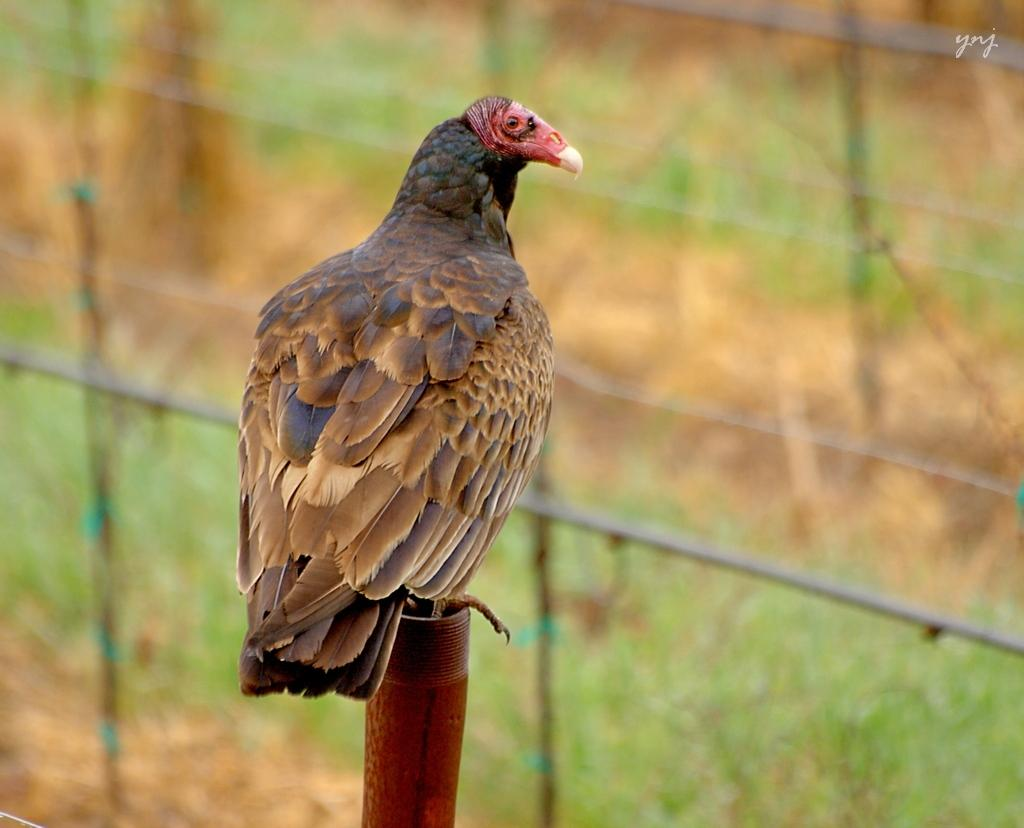What type of animal is in the image? There is a bird in the image. Where is the bird located in the image? The bird is sitting on a wall. Can you describe the position of the bird in the image? The bird is in the middle of the image. What type of blade is the bird using to cut the wall in the image? There is no blade present in the image, and the bird is not cutting the wall. 